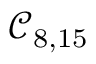Convert formula to latex. <formula><loc_0><loc_0><loc_500><loc_500>\mathcal { C } _ { 8 , 1 5 }</formula> 